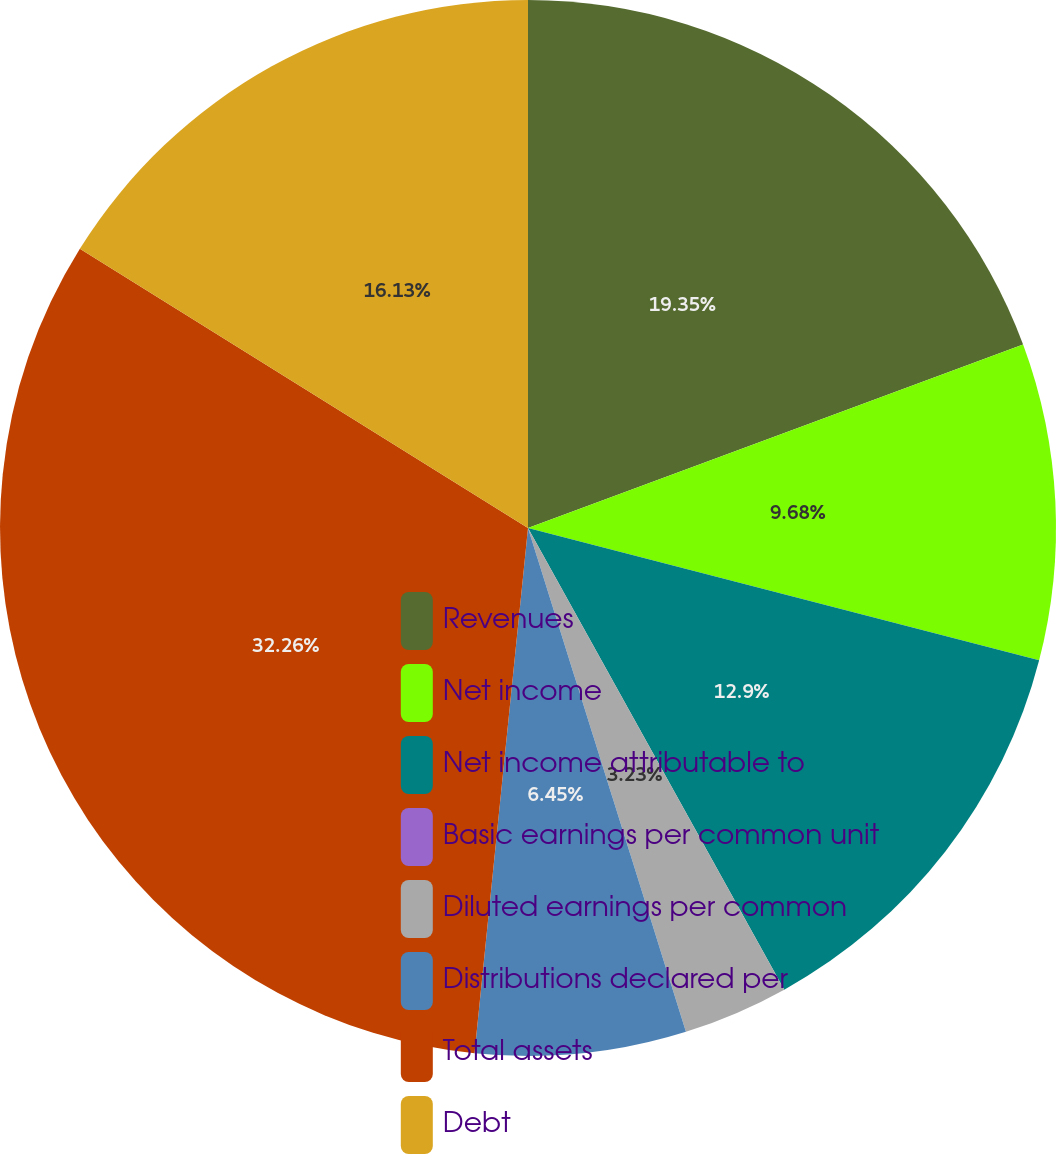<chart> <loc_0><loc_0><loc_500><loc_500><pie_chart><fcel>Revenues<fcel>Net income<fcel>Net income attributable to<fcel>Basic earnings per common unit<fcel>Diluted earnings per common<fcel>Distributions declared per<fcel>Total assets<fcel>Debt<nl><fcel>19.35%<fcel>9.68%<fcel>12.9%<fcel>0.0%<fcel>3.23%<fcel>6.45%<fcel>32.25%<fcel>16.13%<nl></chart> 